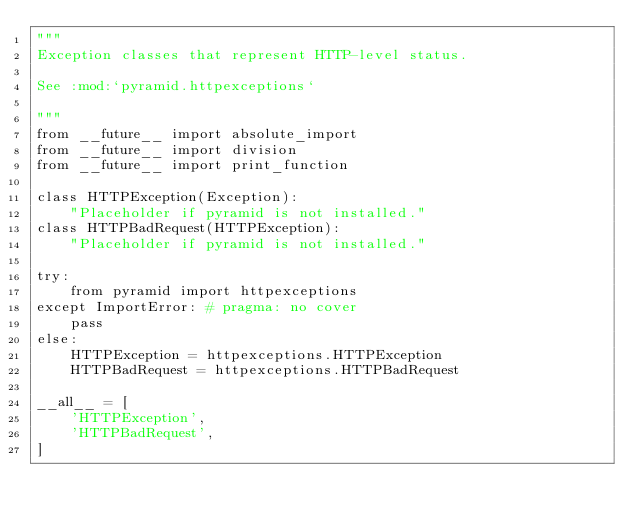Convert code to text. <code><loc_0><loc_0><loc_500><loc_500><_Python_>"""
Exception classes that represent HTTP-level status.

See :mod:`pyramid.httpexceptions`

"""
from __future__ import absolute_import
from __future__ import division
from __future__ import print_function

class HTTPException(Exception):
    "Placeholder if pyramid is not installed."
class HTTPBadRequest(HTTPException):
    "Placeholder if pyramid is not installed."

try:
    from pyramid import httpexceptions
except ImportError: # pragma: no cover
    pass
else:
    HTTPException = httpexceptions.HTTPException
    HTTPBadRequest = httpexceptions.HTTPBadRequest

__all__ = [
    'HTTPException',
    'HTTPBadRequest',
]
</code> 